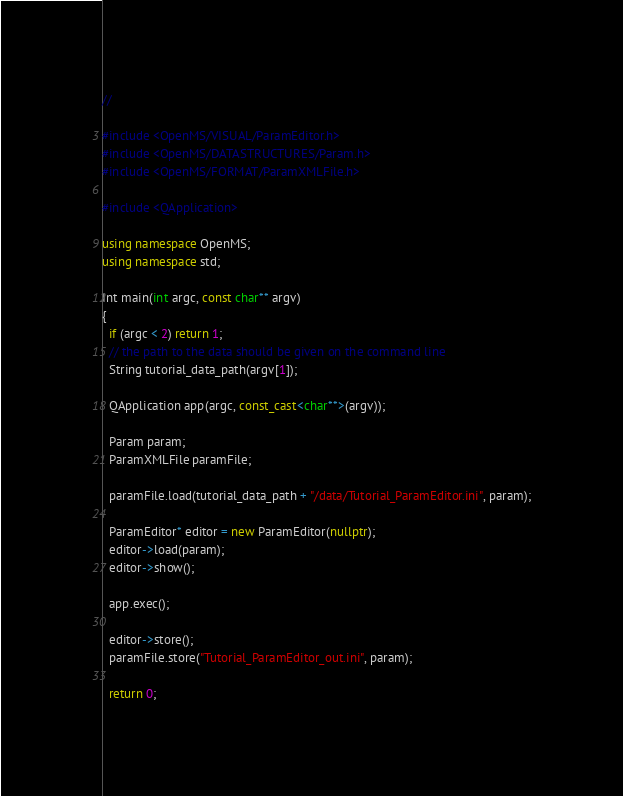<code> <loc_0><loc_0><loc_500><loc_500><_C++_>//

#include <OpenMS/VISUAL/ParamEditor.h>
#include <OpenMS/DATASTRUCTURES/Param.h>
#include <OpenMS/FORMAT/ParamXMLFile.h>

#include <QApplication>

using namespace OpenMS;
using namespace std;

Int main(int argc, const char** argv)
{
  if (argc < 2) return 1;
  // the path to the data should be given on the command line
  String tutorial_data_path(argv[1]);
  
  QApplication app(argc, const_cast<char**>(argv));

  Param param;
  ParamXMLFile paramFile;

  paramFile.load(tutorial_data_path + "/data/Tutorial_ParamEditor.ini", param);

  ParamEditor* editor = new ParamEditor(nullptr);
  editor->load(param);
  editor->show();

  app.exec();

  editor->store();
  paramFile.store("Tutorial_ParamEditor_out.ini", param);

  return 0;</code> 